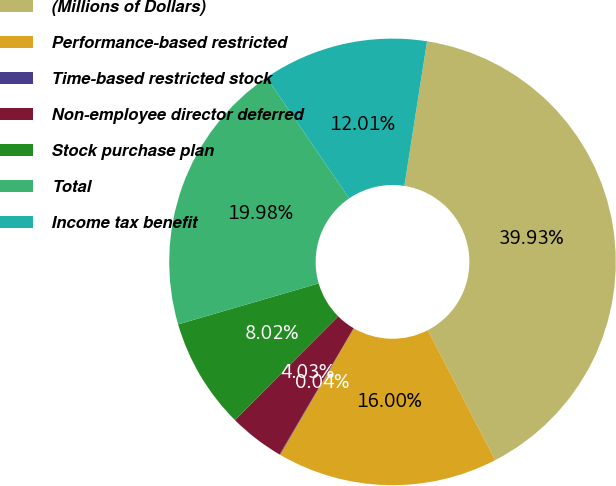Convert chart. <chart><loc_0><loc_0><loc_500><loc_500><pie_chart><fcel>(Millions of Dollars)<fcel>Performance-based restricted<fcel>Time-based restricted stock<fcel>Non-employee director deferred<fcel>Stock purchase plan<fcel>Total<fcel>Income tax benefit<nl><fcel>39.93%<fcel>16.0%<fcel>0.04%<fcel>4.03%<fcel>8.02%<fcel>19.98%<fcel>12.01%<nl></chart> 